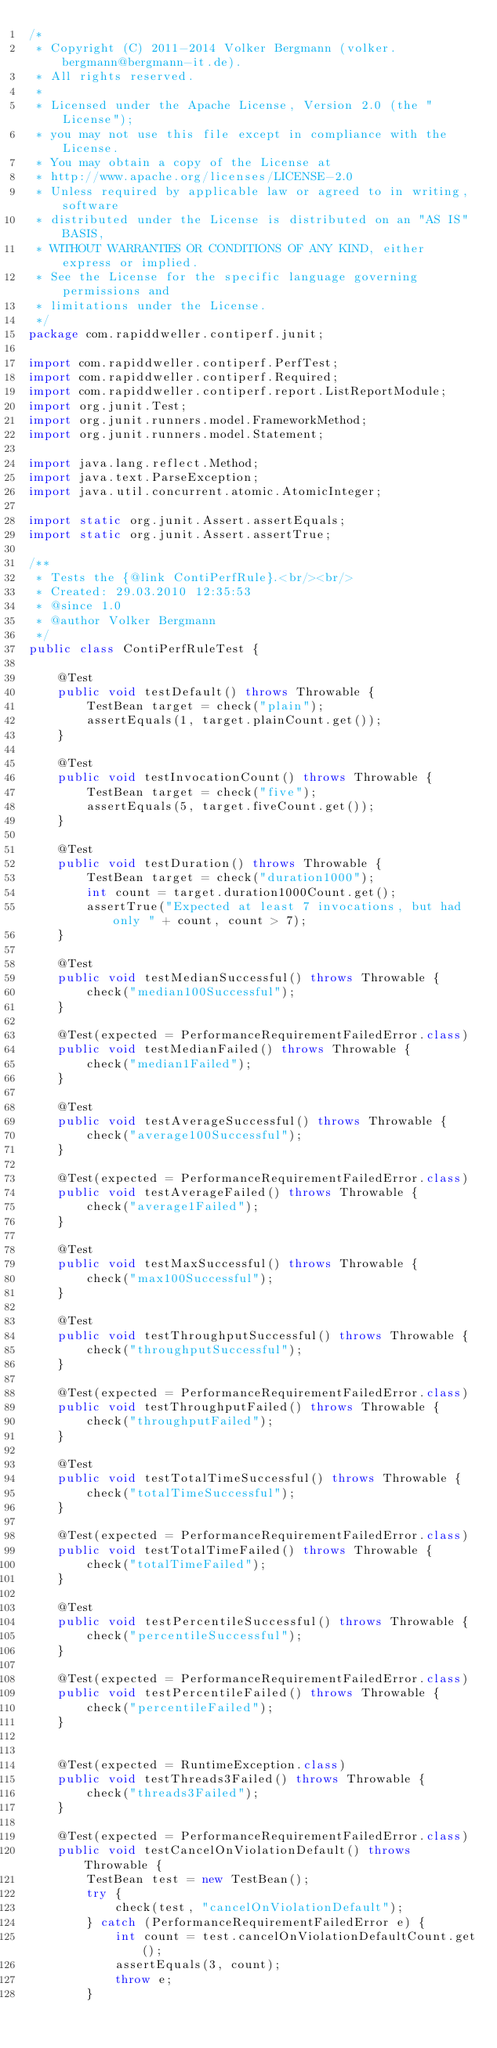<code> <loc_0><loc_0><loc_500><loc_500><_Java_>/*
 * Copyright (C) 2011-2014 Volker Bergmann (volker.bergmann@bergmann-it.de).
 * All rights reserved.
 *
 * Licensed under the Apache License, Version 2.0 (the "License");
 * you may not use this file except in compliance with the License.
 * You may obtain a copy of the License at
 * http://www.apache.org/licenses/LICENSE-2.0
 * Unless required by applicable law or agreed to in writing, software
 * distributed under the License is distributed on an "AS IS" BASIS,
 * WITHOUT WARRANTIES OR CONDITIONS OF ANY KIND, either express or implied.
 * See the License for the specific language governing permissions and
 * limitations under the License.
 */
package com.rapiddweller.contiperf.junit;

import com.rapiddweller.contiperf.PerfTest;
import com.rapiddweller.contiperf.Required;
import com.rapiddweller.contiperf.report.ListReportModule;
import org.junit.Test;
import org.junit.runners.model.FrameworkMethod;
import org.junit.runners.model.Statement;

import java.lang.reflect.Method;
import java.text.ParseException;
import java.util.concurrent.atomic.AtomicInteger;

import static org.junit.Assert.assertEquals;
import static org.junit.Assert.assertTrue;

/**
 * Tests the {@link ContiPerfRule}.<br/><br/>
 * Created: 29.03.2010 12:35:53
 * @since 1.0
 * @author Volker Bergmann
 */
public class ContiPerfRuleTest {

	@Test
	public void testDefault() throws Throwable {
		TestBean target = check("plain");
		assertEquals(1, target.plainCount.get());
	}

	@Test
	public void testInvocationCount() throws Throwable {
		TestBean target = check("five");
		assertEquals(5, target.fiveCount.get());
	}

	@Test
	public void testDuration() throws Throwable {
		TestBean target = check("duration1000");
		int count = target.duration1000Count.get();
		assertTrue("Expected at least 7 invocations, but had only " + count, count > 7);
	}

	@Test
	public void testMedianSuccessful() throws Throwable {
		check("median100Successful");
	}

	@Test(expected = PerformanceRequirementFailedError.class)
	public void testMedianFailed() throws Throwable {
		check("median1Failed");
	}

	@Test
	public void testAverageSuccessful() throws Throwable {
		check("average100Successful");
	}

	@Test(expected = PerformanceRequirementFailedError.class)
	public void testAverageFailed() throws Throwable {
		check("average1Failed");
	}

	@Test
	public void testMaxSuccessful() throws Throwable {
		check("max100Successful");
	}

	@Test
	public void testThroughputSuccessful() throws Throwable {
		check("throughputSuccessful");
	}
	
	@Test(expected = PerformanceRequirementFailedError.class)
	public void testThroughputFailed() throws Throwable {
		check("throughputFailed");
	}
	
	@Test
	public void testTotalTimeSuccessful() throws Throwable {
		check("totalTimeSuccessful");
	}
	
	@Test(expected = PerformanceRequirementFailedError.class)
	public void testTotalTimeFailed() throws Throwable {
		check("totalTimeFailed");
	}
	
	@Test
	public void testPercentileSuccessful() throws Throwable {
		check("percentileSuccessful");
	}
	
	@Test(expected = PerformanceRequirementFailedError.class)
	public void testPercentileFailed() throws Throwable {
		check("percentileFailed");
	}

	
	@Test(expected = RuntimeException.class)
	public void testThreads3Failed() throws Throwable {
		check("threads3Failed");
	}
	
	@Test(expected = PerformanceRequirementFailedError.class)
	public void testCancelOnViolationDefault() throws Throwable {
		TestBean test = new TestBean();
		try {
			check(test, "cancelOnViolationDefault");
		} catch (PerformanceRequirementFailedError e) {
			int count = test.cancelOnViolationDefaultCount.get();
			assertEquals(3, count);
			throw e;
		}</code> 